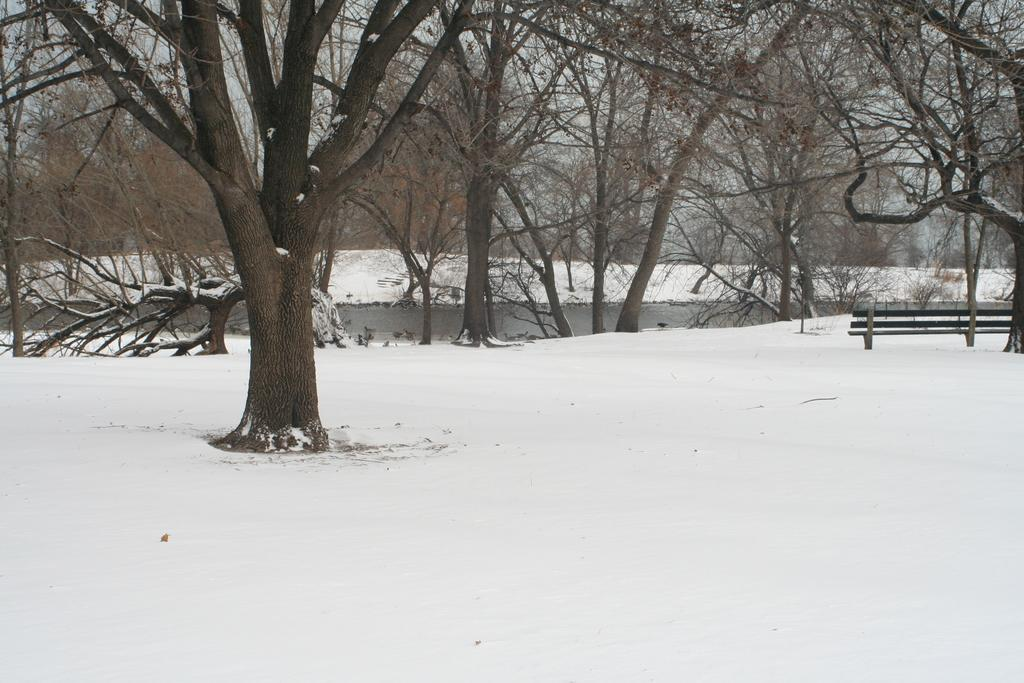What is located in the center of the image? There are trees in the center of the image. What can be seen on the right side of the image? There is a bench on the right side of the image. What type of weather condition is depicted in the image? There is snow visible at the bottom of the image, indicating a snowy environment. Where is the soap and pail located in the image? There is no soap or pail present in the image. What type of credit can be seen on the trees in the image? There is no credit or any financial information depicted on the trees in the image. 